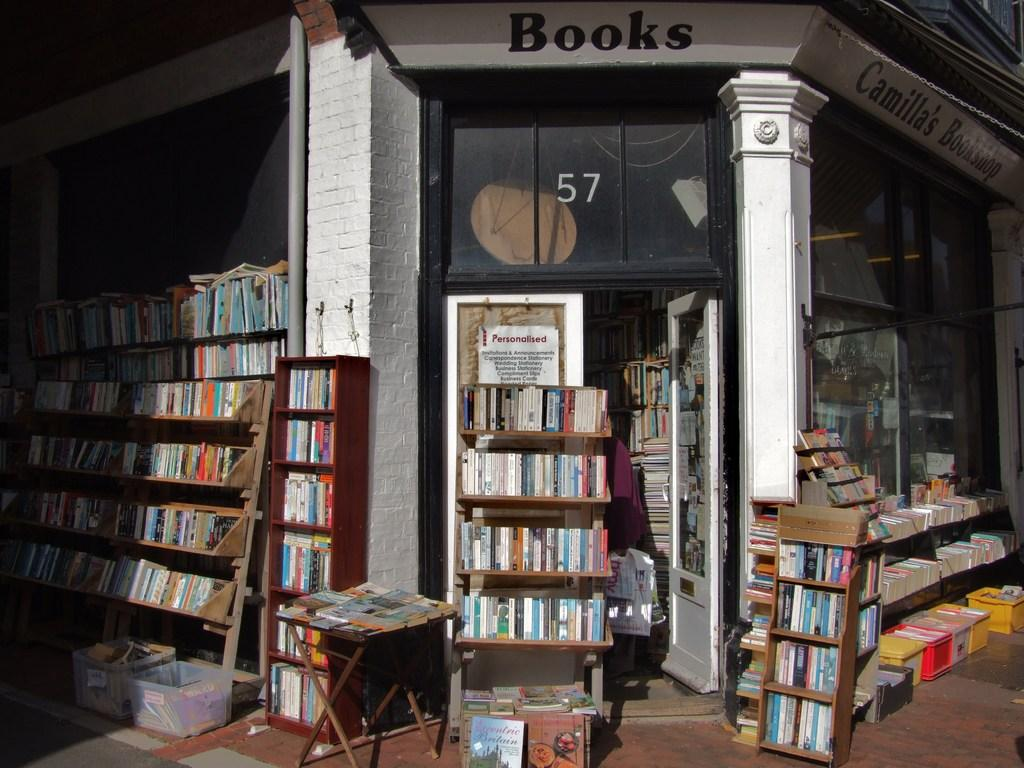<image>
Offer a succinct explanation of the picture presented. Old Library with stacks of books that is store # 57. 